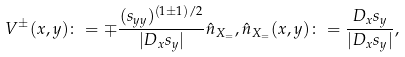<formula> <loc_0><loc_0><loc_500><loc_500>V ^ { \pm } ( x , y ) \colon = \mp \frac { ( s _ { y y } ) ^ { ( 1 \pm 1 ) / 2 } } { | D _ { x } s _ { y } | } \hat { n } _ { X _ { = } } , \hat { n } _ { X _ { = } } ( x , y ) \colon = \frac { D _ { x } s _ { y } } { | D _ { x } s _ { y } | } ,</formula> 